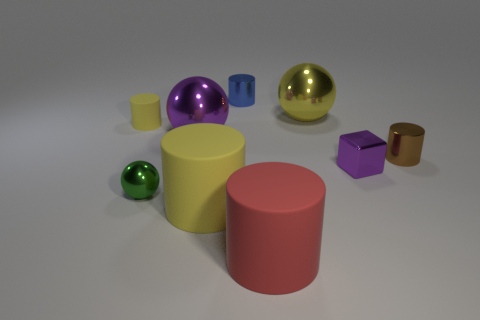Subtract all metallic cylinders. How many cylinders are left? 3 Subtract all blue cylinders. How many cylinders are left? 4 Add 7 red cylinders. How many red cylinders are left? 8 Add 3 red blocks. How many red blocks exist? 3 Add 1 large purple things. How many objects exist? 10 Subtract 0 red spheres. How many objects are left? 9 Subtract all balls. How many objects are left? 6 Subtract 2 cylinders. How many cylinders are left? 3 Subtract all gray blocks. Subtract all brown cylinders. How many blocks are left? 1 Subtract all yellow cylinders. How many purple spheres are left? 1 